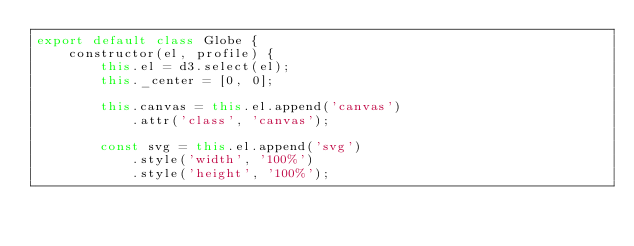<code> <loc_0><loc_0><loc_500><loc_500><_JavaScript_>export default class Globe {
    constructor(el, profile) {
	    this.el = d3.select(el);
	    this._center = [0, 0];

	    this.canvas = this.el.append('canvas')
		    .attr('class', 'canvas');

	    const svg = this.el.append('svg')
		    .style('width', '100%')
		    .style('height', '100%');
</code> 